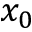<formula> <loc_0><loc_0><loc_500><loc_500>x _ { 0 }</formula> 